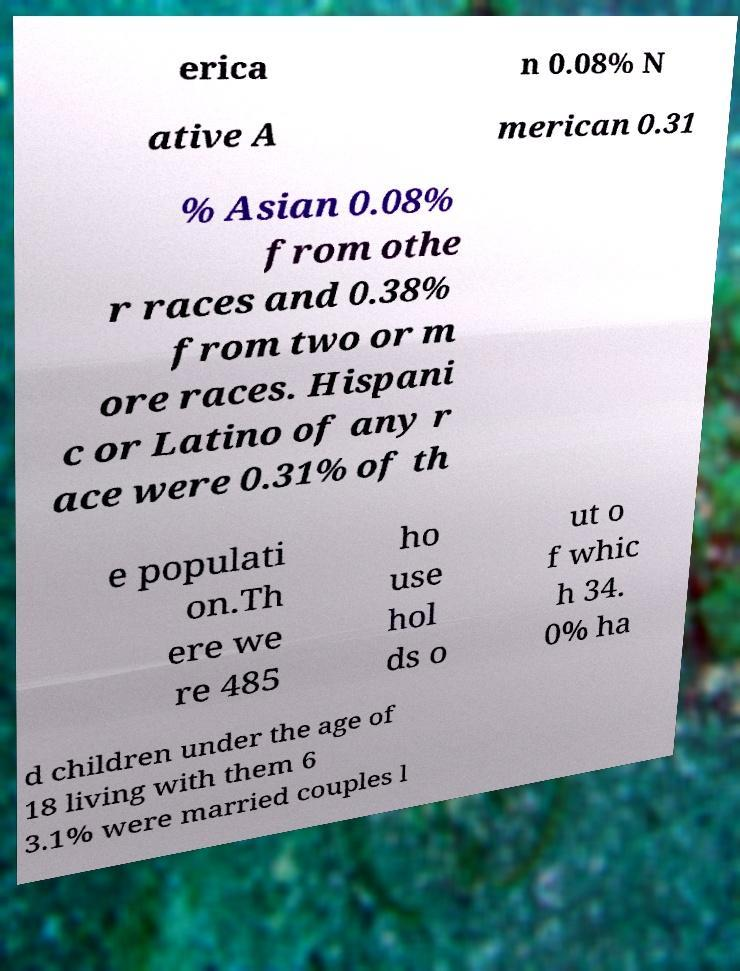What messages or text are displayed in this image? I need them in a readable, typed format. erica n 0.08% N ative A merican 0.31 % Asian 0.08% from othe r races and 0.38% from two or m ore races. Hispani c or Latino of any r ace were 0.31% of th e populati on.Th ere we re 485 ho use hol ds o ut o f whic h 34. 0% ha d children under the age of 18 living with them 6 3.1% were married couples l 